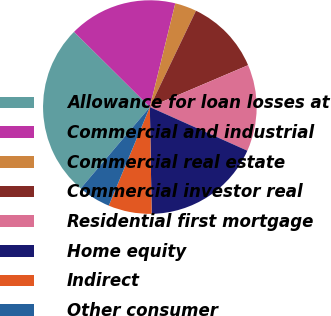Convert chart to OTSL. <chart><loc_0><loc_0><loc_500><loc_500><pie_chart><fcel>Allowance for loan losses at<fcel>Commercial and industrial<fcel>Commercial real estate<fcel>Commercial investor real<fcel>Residential first mortgage<fcel>Home equity<fcel>Indirect<fcel>Other consumer<nl><fcel>26.23%<fcel>16.39%<fcel>3.28%<fcel>11.48%<fcel>13.11%<fcel>18.03%<fcel>6.56%<fcel>4.92%<nl></chart> 